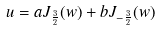<formula> <loc_0><loc_0><loc_500><loc_500>u = a J _ { \frac { 3 } { 2 } } ( w ) + b J _ { - \frac { 3 } { 2 } } ( w )</formula> 